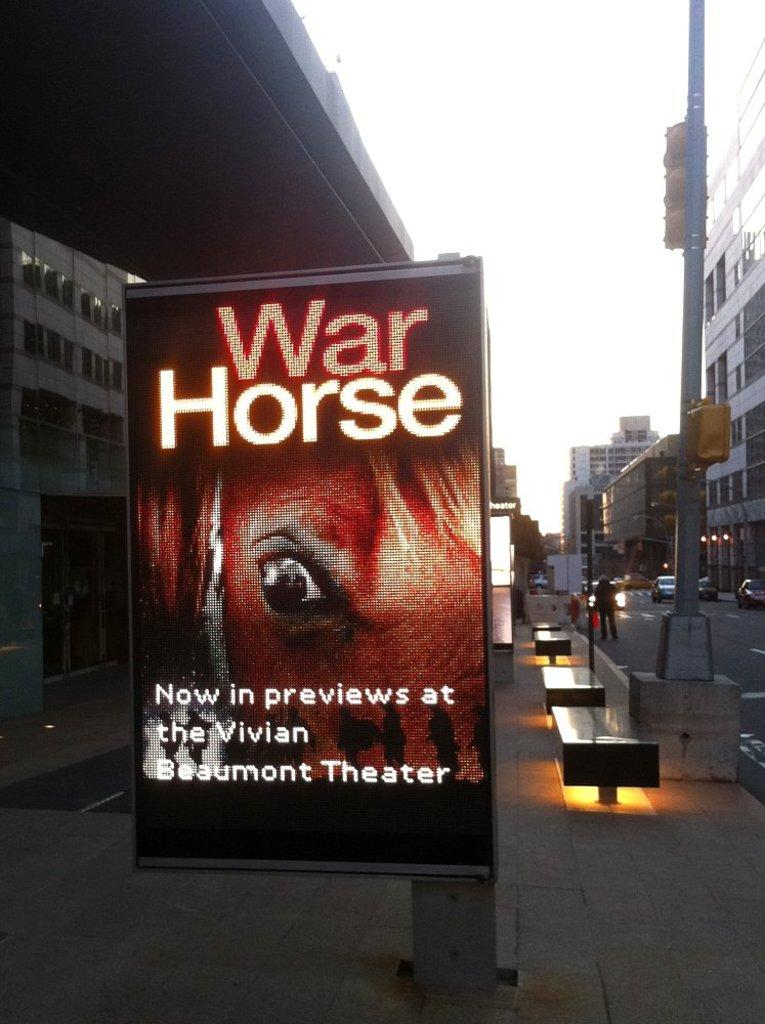<image>
Render a clear and concise summary of the photo. An electronic sign next to a street advertises the movie preview of "War Horse". 